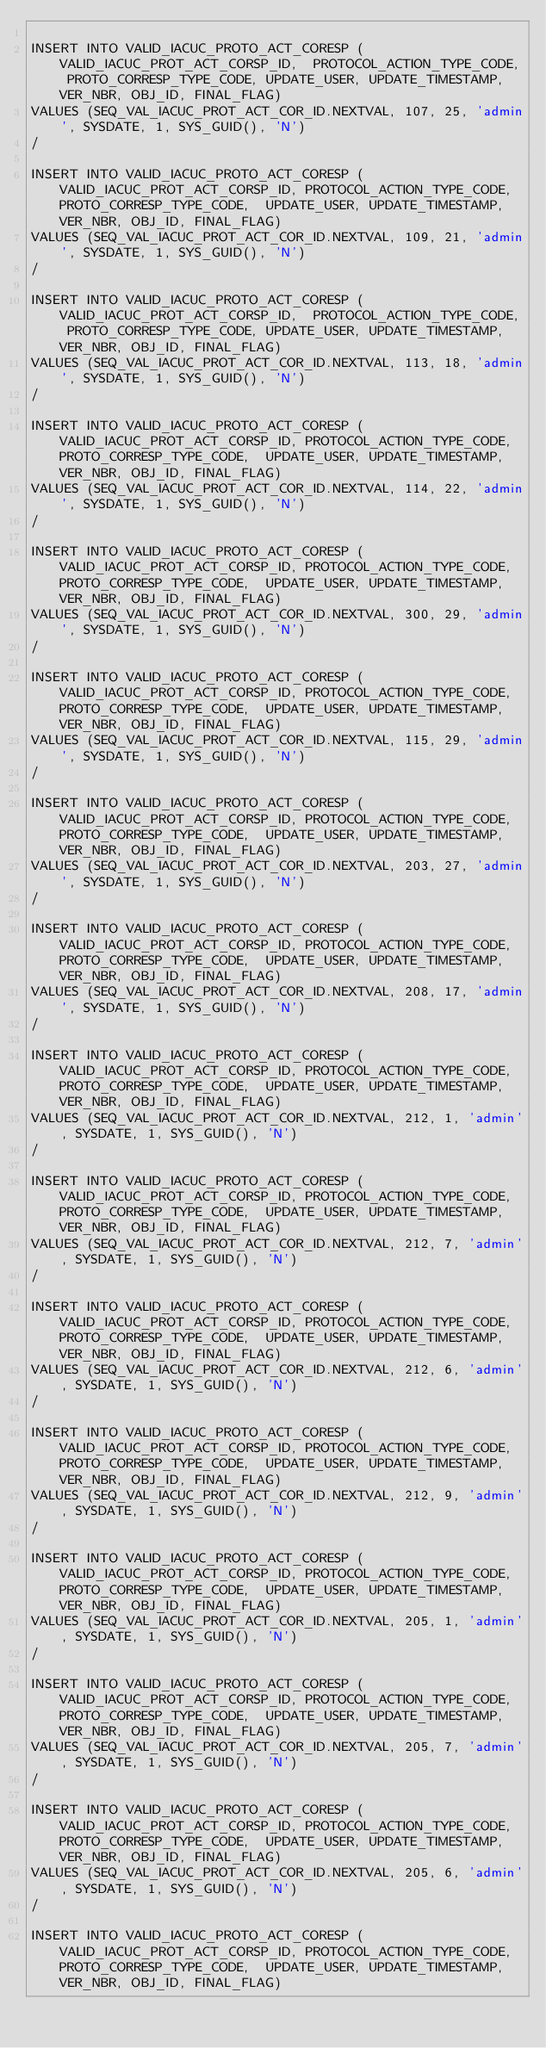<code> <loc_0><loc_0><loc_500><loc_500><_SQL_>
INSERT INTO VALID_IACUC_PROTO_ACT_CORESP (VALID_IACUC_PROT_ACT_CORSP_ID,	PROTOCOL_ACTION_TYPE_CODE, PROTO_CORRESP_TYPE_CODE,	UPDATE_USER, UPDATE_TIMESTAMP, VER_NBR, OBJ_ID, FINAL_FLAG) 
VALUES (SEQ_VAL_IACUC_PROT_ACT_COR_ID.NEXTVAL, 107, 25,	'admin', SYSDATE, 1, SYS_GUID(), 'N')
/

INSERT INTO VALID_IACUC_PROTO_ACT_CORESP (VALID_IACUC_PROT_ACT_CORSP_ID, PROTOCOL_ACTION_TYPE_CODE, PROTO_CORRESP_TYPE_CODE,	UPDATE_USER, UPDATE_TIMESTAMP, VER_NBR, OBJ_ID, FINAL_FLAG) 
VALUES (SEQ_VAL_IACUC_PROT_ACT_COR_ID.NEXTVAL, 109, 21, 'admin', SYSDATE, 1, SYS_GUID(), 'N')
/

INSERT INTO VALID_IACUC_PROTO_ACT_CORESP (VALID_IACUC_PROT_ACT_CORSP_ID,	PROTOCOL_ACTION_TYPE_CODE, PROTO_CORRESP_TYPE_CODE,	UPDATE_USER, UPDATE_TIMESTAMP, VER_NBR, OBJ_ID, FINAL_FLAG) 
VALUES (SEQ_VAL_IACUC_PROT_ACT_COR_ID.NEXTVAL, 113, 18,	'admin', SYSDATE, 1, SYS_GUID(), 'N')
/

INSERT INTO VALID_IACUC_PROTO_ACT_CORESP (VALID_IACUC_PROT_ACT_CORSP_ID, PROTOCOL_ACTION_TYPE_CODE, PROTO_CORRESP_TYPE_CODE,	UPDATE_USER, UPDATE_TIMESTAMP, VER_NBR, OBJ_ID, FINAL_FLAG) 
VALUES (SEQ_VAL_IACUC_PROT_ACT_COR_ID.NEXTVAL, 114, 22,	'admin', SYSDATE, 1, SYS_GUID(), 'N')
/

INSERT INTO VALID_IACUC_PROTO_ACT_CORESP (VALID_IACUC_PROT_ACT_CORSP_ID, PROTOCOL_ACTION_TYPE_CODE, PROTO_CORRESP_TYPE_CODE,	UPDATE_USER, UPDATE_TIMESTAMP, VER_NBR, OBJ_ID, FINAL_FLAG) 
VALUES (SEQ_VAL_IACUC_PROT_ACT_COR_ID.NEXTVAL, 300, 29,	'admin', SYSDATE, 1, SYS_GUID(), 'N')
/

INSERT INTO VALID_IACUC_PROTO_ACT_CORESP (VALID_IACUC_PROT_ACT_CORSP_ID, PROTOCOL_ACTION_TYPE_CODE, PROTO_CORRESP_TYPE_CODE,	UPDATE_USER, UPDATE_TIMESTAMP, VER_NBR, OBJ_ID, FINAL_FLAG) 
VALUES (SEQ_VAL_IACUC_PROT_ACT_COR_ID.NEXTVAL, 115, 29,	'admin', SYSDATE, 1, SYS_GUID(), 'N')
/

INSERT INTO VALID_IACUC_PROTO_ACT_CORESP (VALID_IACUC_PROT_ACT_CORSP_ID, PROTOCOL_ACTION_TYPE_CODE, PROTO_CORRESP_TYPE_CODE,	UPDATE_USER, UPDATE_TIMESTAMP, VER_NBR, OBJ_ID, FINAL_FLAG) 
VALUES (SEQ_VAL_IACUC_PROT_ACT_COR_ID.NEXTVAL, 203, 27,	'admin', SYSDATE, 1, SYS_GUID(), 'N')
/

INSERT INTO VALID_IACUC_PROTO_ACT_CORESP (VALID_IACUC_PROT_ACT_CORSP_ID, PROTOCOL_ACTION_TYPE_CODE, PROTO_CORRESP_TYPE_CODE,	UPDATE_USER, UPDATE_TIMESTAMP, VER_NBR, OBJ_ID, FINAL_FLAG) 
VALUES (SEQ_VAL_IACUC_PROT_ACT_COR_ID.NEXTVAL, 208, 17,	'admin', SYSDATE, 1, SYS_GUID(), 'N')
/

INSERT INTO VALID_IACUC_PROTO_ACT_CORESP (VALID_IACUC_PROT_ACT_CORSP_ID, PROTOCOL_ACTION_TYPE_CODE, PROTO_CORRESP_TYPE_CODE,	UPDATE_USER, UPDATE_TIMESTAMP, VER_NBR, OBJ_ID, FINAL_FLAG) 
VALUES (SEQ_VAL_IACUC_PROT_ACT_COR_ID.NEXTVAL, 212, 1, 'admin', SYSDATE, 1, SYS_GUID(), 'N')
/

INSERT INTO VALID_IACUC_PROTO_ACT_CORESP (VALID_IACUC_PROT_ACT_CORSP_ID, PROTOCOL_ACTION_TYPE_CODE, PROTO_CORRESP_TYPE_CODE,	UPDATE_USER, UPDATE_TIMESTAMP, VER_NBR, OBJ_ID, FINAL_FLAG) 
VALUES (SEQ_VAL_IACUC_PROT_ACT_COR_ID.NEXTVAL, 212, 7, 'admin', SYSDATE, 1, SYS_GUID(), 'N')
/

INSERT INTO VALID_IACUC_PROTO_ACT_CORESP (VALID_IACUC_PROT_ACT_CORSP_ID, PROTOCOL_ACTION_TYPE_CODE, PROTO_CORRESP_TYPE_CODE,	UPDATE_USER, UPDATE_TIMESTAMP, VER_NBR, OBJ_ID, FINAL_FLAG) 
VALUES (SEQ_VAL_IACUC_PROT_ACT_COR_ID.NEXTVAL, 212, 6, 'admin', SYSDATE, 1, SYS_GUID(), 'N')
/

INSERT INTO VALID_IACUC_PROTO_ACT_CORESP (VALID_IACUC_PROT_ACT_CORSP_ID, PROTOCOL_ACTION_TYPE_CODE, PROTO_CORRESP_TYPE_CODE,	UPDATE_USER, UPDATE_TIMESTAMP, VER_NBR, OBJ_ID, FINAL_FLAG) 
VALUES (SEQ_VAL_IACUC_PROT_ACT_COR_ID.NEXTVAL, 212, 9, 'admin', SYSDATE, 1, SYS_GUID(), 'N')
/

INSERT INTO VALID_IACUC_PROTO_ACT_CORESP (VALID_IACUC_PROT_ACT_CORSP_ID, PROTOCOL_ACTION_TYPE_CODE, PROTO_CORRESP_TYPE_CODE,	UPDATE_USER, UPDATE_TIMESTAMP, VER_NBR, OBJ_ID, FINAL_FLAG) 
VALUES (SEQ_VAL_IACUC_PROT_ACT_COR_ID.NEXTVAL, 205, 1, 'admin', SYSDATE, 1, SYS_GUID(), 'N')
/

INSERT INTO VALID_IACUC_PROTO_ACT_CORESP (VALID_IACUC_PROT_ACT_CORSP_ID, PROTOCOL_ACTION_TYPE_CODE, PROTO_CORRESP_TYPE_CODE,	UPDATE_USER, UPDATE_TIMESTAMP, VER_NBR, OBJ_ID, FINAL_FLAG) 
VALUES (SEQ_VAL_IACUC_PROT_ACT_COR_ID.NEXTVAL, 205, 7, 'admin', SYSDATE, 1, SYS_GUID(), 'N')
/

INSERT INTO VALID_IACUC_PROTO_ACT_CORESP (VALID_IACUC_PROT_ACT_CORSP_ID, PROTOCOL_ACTION_TYPE_CODE, PROTO_CORRESP_TYPE_CODE,	UPDATE_USER, UPDATE_TIMESTAMP, VER_NBR, OBJ_ID, FINAL_FLAG) 
VALUES (SEQ_VAL_IACUC_PROT_ACT_COR_ID.NEXTVAL, 205, 6, 'admin', SYSDATE, 1, SYS_GUID(), 'N')
/

INSERT INTO VALID_IACUC_PROTO_ACT_CORESP (VALID_IACUC_PROT_ACT_CORSP_ID, PROTOCOL_ACTION_TYPE_CODE, PROTO_CORRESP_TYPE_CODE,	UPDATE_USER, UPDATE_TIMESTAMP, VER_NBR, OBJ_ID, FINAL_FLAG) </code> 